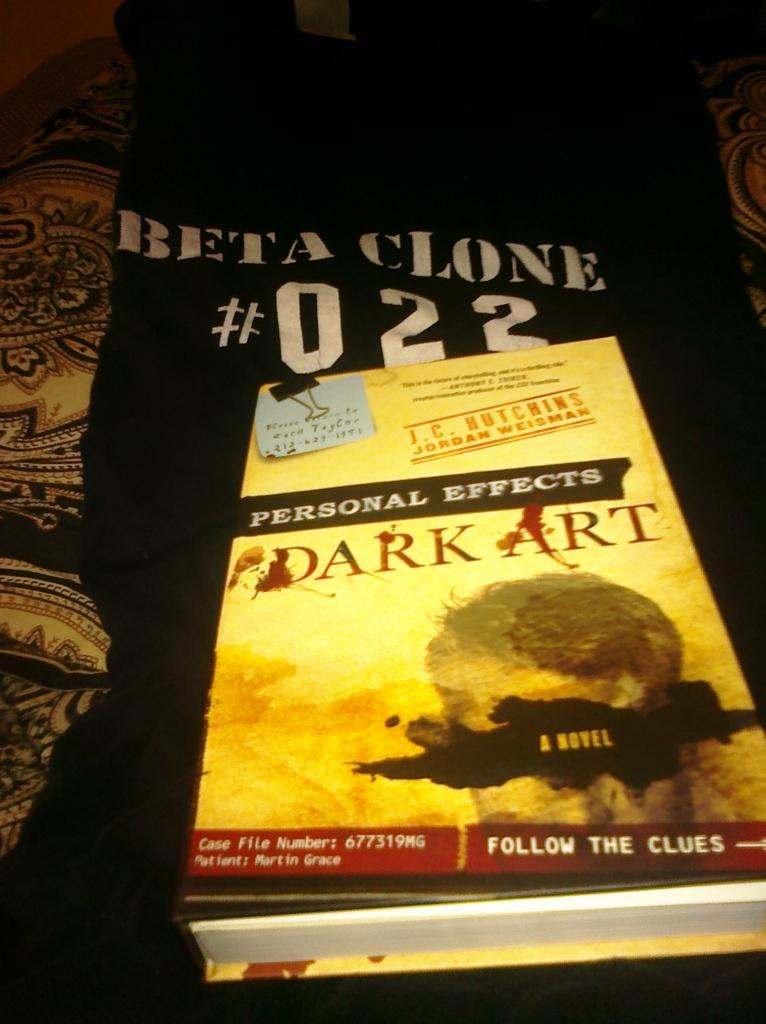<image>
Render a clear and concise summary of the photo. A book titled Personal Effects Dark ARt laying on top of a black t-shirt. 